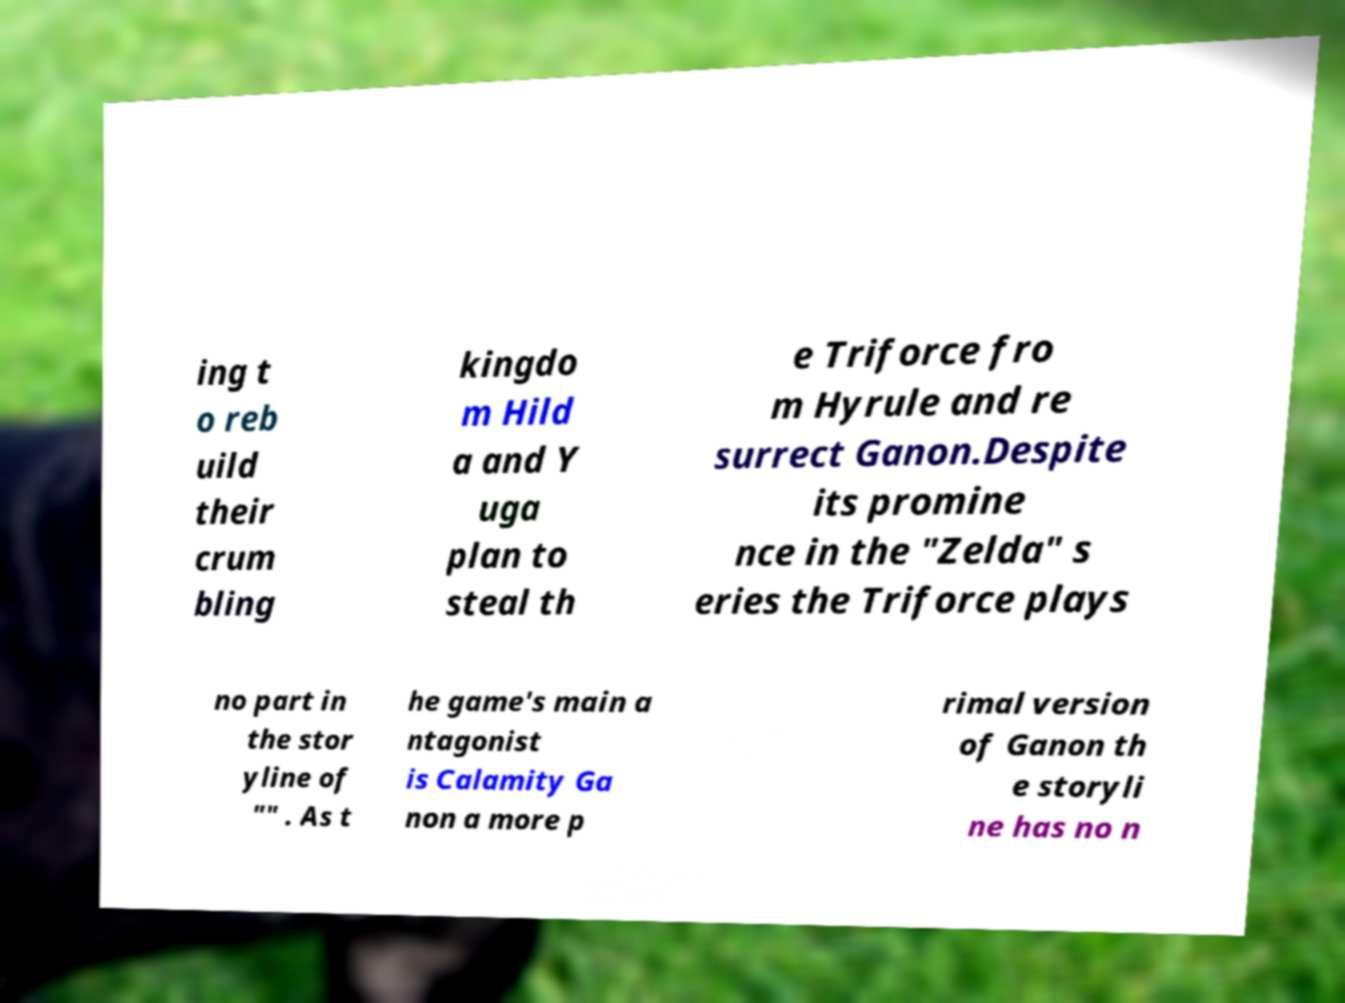Can you accurately transcribe the text from the provided image for me? ing t o reb uild their crum bling kingdo m Hild a and Y uga plan to steal th e Triforce fro m Hyrule and re surrect Ganon.Despite its promine nce in the "Zelda" s eries the Triforce plays no part in the stor yline of "" . As t he game's main a ntagonist is Calamity Ga non a more p rimal version of Ganon th e storyli ne has no n 